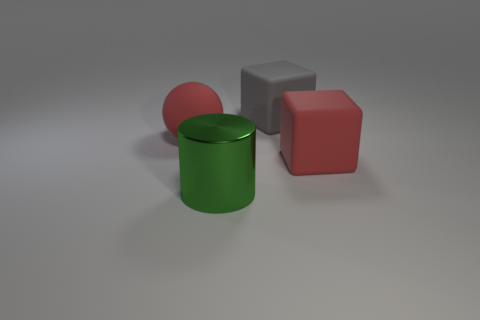Are there any other things that are made of the same material as the large green cylinder?
Your answer should be very brief. No. There is a red matte object that is on the right side of the large ball; is its shape the same as the green thing?
Your response must be concise. No. How many things are metal objects or red balls?
Give a very brief answer. 2. There is a big object that is both to the right of the big shiny cylinder and in front of the gray rubber object; what is it made of?
Keep it short and to the point. Rubber. There is a red thing that is behind the red matte thing on the right side of the green cylinder; what size is it?
Keep it short and to the point. Large. How many objects are both to the right of the big shiny thing and in front of the ball?
Provide a short and direct response. 1. Are there any big green cylinders that are on the right side of the large red object that is behind the large red rubber thing that is on the right side of the matte sphere?
Your answer should be very brief. Yes. What shape is the green metal object that is the same size as the sphere?
Offer a very short reply. Cylinder. Is there a matte thing that has the same color as the sphere?
Your answer should be compact. Yes. How many large things are metal cylinders or rubber things?
Keep it short and to the point. 4. 